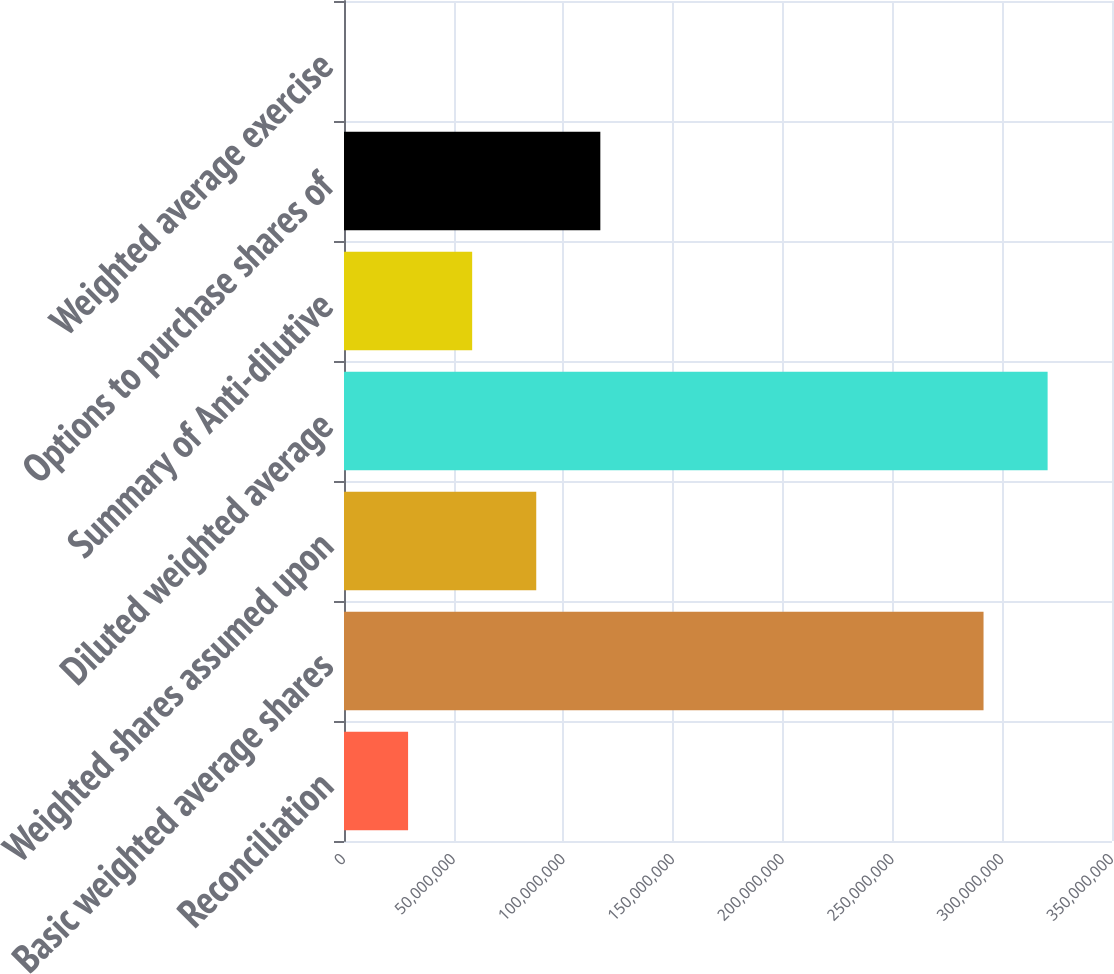Convert chart. <chart><loc_0><loc_0><loc_500><loc_500><bar_chart><fcel>Reconciliation<fcel>Basic weighted average shares<fcel>Weighted shares assumed upon<fcel>Diluted weighted average<fcel>Summary of Anti-dilutive<fcel>Options to purchase shares of<fcel>Weighted average exercise<nl><fcel>2.92046e+07<fcel>2.91453e+08<fcel>8.76137e+07<fcel>3.20658e+08<fcel>5.84091e+07<fcel>1.16818e+08<fcel>51.89<nl></chart> 